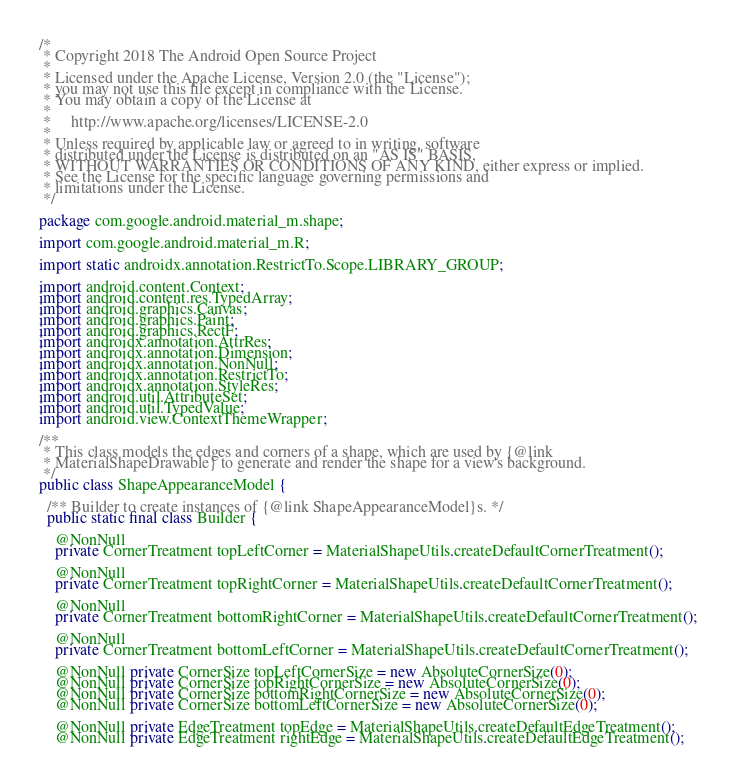Convert code to text. <code><loc_0><loc_0><loc_500><loc_500><_Java_>/*
 * Copyright 2018 The Android Open Source Project
 *
 * Licensed under the Apache License, Version 2.0 (the "License");
 * you may not use this file except in compliance with the License.
 * You may obtain a copy of the License at
 *
 *     http://www.apache.org/licenses/LICENSE-2.0
 *
 * Unless required by applicable law or agreed to in writing, software
 * distributed under the License is distributed on an "AS IS" BASIS,
 * WITHOUT WARRANTIES OR CONDITIONS OF ANY KIND, either express or implied.
 * See the License for the specific language governing permissions and
 * limitations under the License.
 */

package com.google.android.material_m.shape;

import com.google.android.material_m.R;

import static androidx.annotation.RestrictTo.Scope.LIBRARY_GROUP;

import android.content.Context;
import android.content.res.TypedArray;
import android.graphics.Canvas;
import android.graphics.Paint;
import android.graphics.RectF;
import androidx.annotation.AttrRes;
import androidx.annotation.Dimension;
import androidx.annotation.NonNull;
import androidx.annotation.RestrictTo;
import androidx.annotation.StyleRes;
import android.util.AttributeSet;
import android.util.TypedValue;
import android.view.ContextThemeWrapper;

/**
 * This class models the edges and corners of a shape, which are used by {@link
 * MaterialShapeDrawable} to generate and render the shape for a view's background.
 */
public class ShapeAppearanceModel {

  /** Builder to create instances of {@link ShapeAppearanceModel}s. */
  public static final class Builder {

    @NonNull
    private CornerTreatment topLeftCorner = MaterialShapeUtils.createDefaultCornerTreatment();

    @NonNull
    private CornerTreatment topRightCorner = MaterialShapeUtils.createDefaultCornerTreatment();

    @NonNull
    private CornerTreatment bottomRightCorner = MaterialShapeUtils.createDefaultCornerTreatment();

    @NonNull
    private CornerTreatment bottomLeftCorner = MaterialShapeUtils.createDefaultCornerTreatment();

    @NonNull private CornerSize topLeftCornerSize = new AbsoluteCornerSize(0);
    @NonNull private CornerSize topRightCornerSize = new AbsoluteCornerSize(0);
    @NonNull private CornerSize bottomRightCornerSize = new AbsoluteCornerSize(0);
    @NonNull private CornerSize bottomLeftCornerSize = new AbsoluteCornerSize(0);

    @NonNull private EdgeTreatment topEdge = MaterialShapeUtils.createDefaultEdgeTreatment();
    @NonNull private EdgeTreatment rightEdge = MaterialShapeUtils.createDefaultEdgeTreatment();</code> 